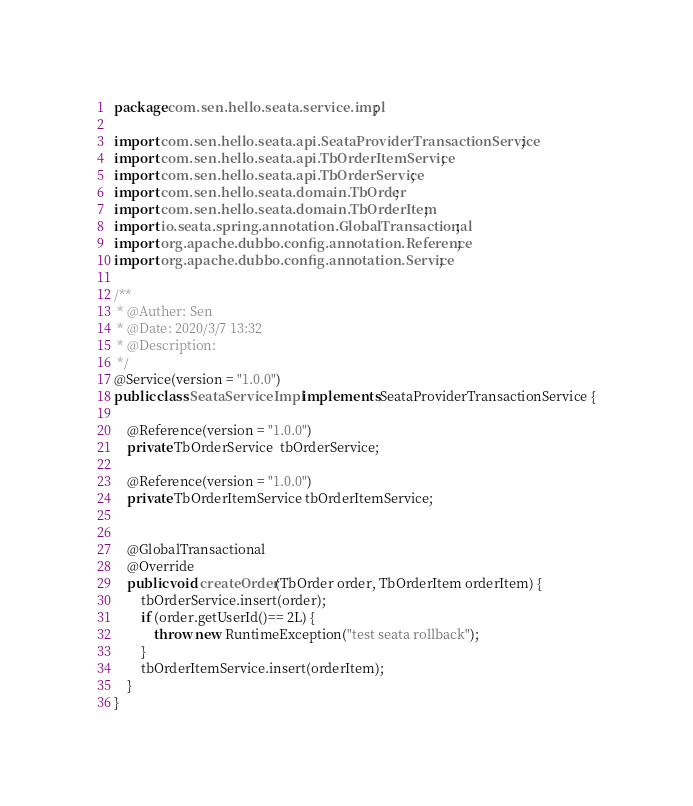<code> <loc_0><loc_0><loc_500><loc_500><_Java_>package com.sen.hello.seata.service.impl;

import com.sen.hello.seata.api.SeataProviderTransactionService;
import com.sen.hello.seata.api.TbOrderItemService;
import com.sen.hello.seata.api.TbOrderService;
import com.sen.hello.seata.domain.TbOrder;
import com.sen.hello.seata.domain.TbOrderItem;
import io.seata.spring.annotation.GlobalTransactional;
import org.apache.dubbo.config.annotation.Reference;
import org.apache.dubbo.config.annotation.Service;

/**
 * @Auther: Sen
 * @Date: 2020/3/7 13:32
 * @Description:
 */
@Service(version = "1.0.0")
public class SeataServiceImpl implements SeataProviderTransactionService {

    @Reference(version = "1.0.0")
    private TbOrderService  tbOrderService;

    @Reference(version = "1.0.0")
    private TbOrderItemService tbOrderItemService;


    @GlobalTransactional
    @Override
    public void createOrder(TbOrder order, TbOrderItem orderItem) {
        tbOrderService.insert(order);
        if (order.getUserId()== 2L) {
            throw new RuntimeException("test seata rollback");
        }
        tbOrderItemService.insert(orderItem);
    }
}
</code> 